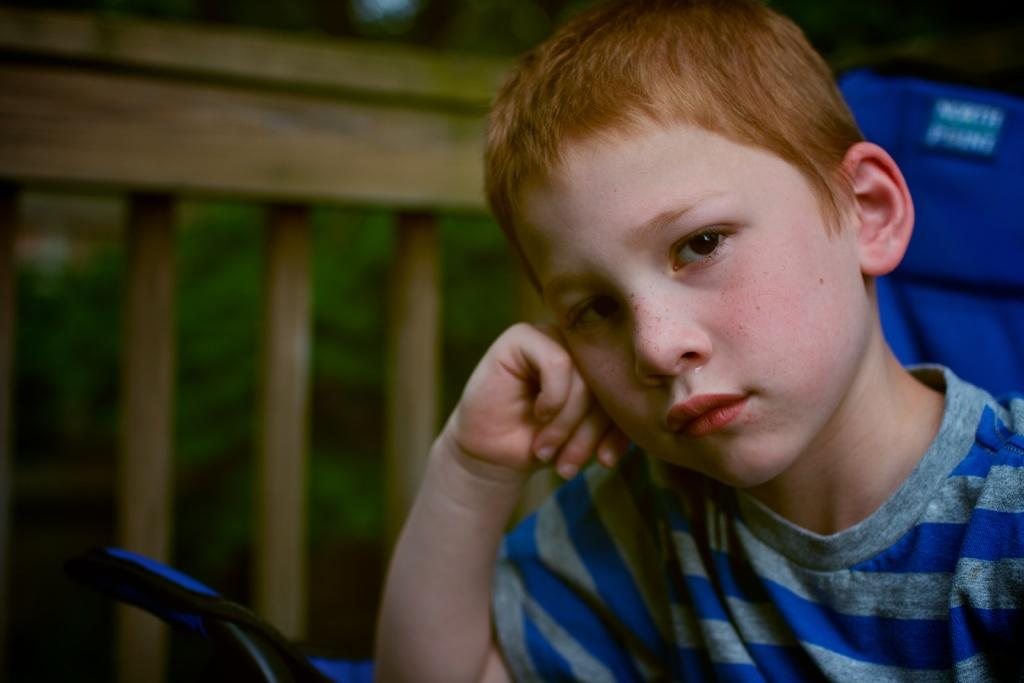Who is present in the image? There is a boy in the image. What can be seen in the background of the image? The background of the image is blurred. What is the unspecified object in the image? Unfortunately, we cannot provide a description of the unspecified object as it is not detailed in the facts. What is the fence in the image used for? The purpose of the fence in the image cannot be determined from the provided facts. What type of soup is being served in the image? There is no soup present in the image. How many pieces of lumber are visible in the image? There is no lumber present in the image. 